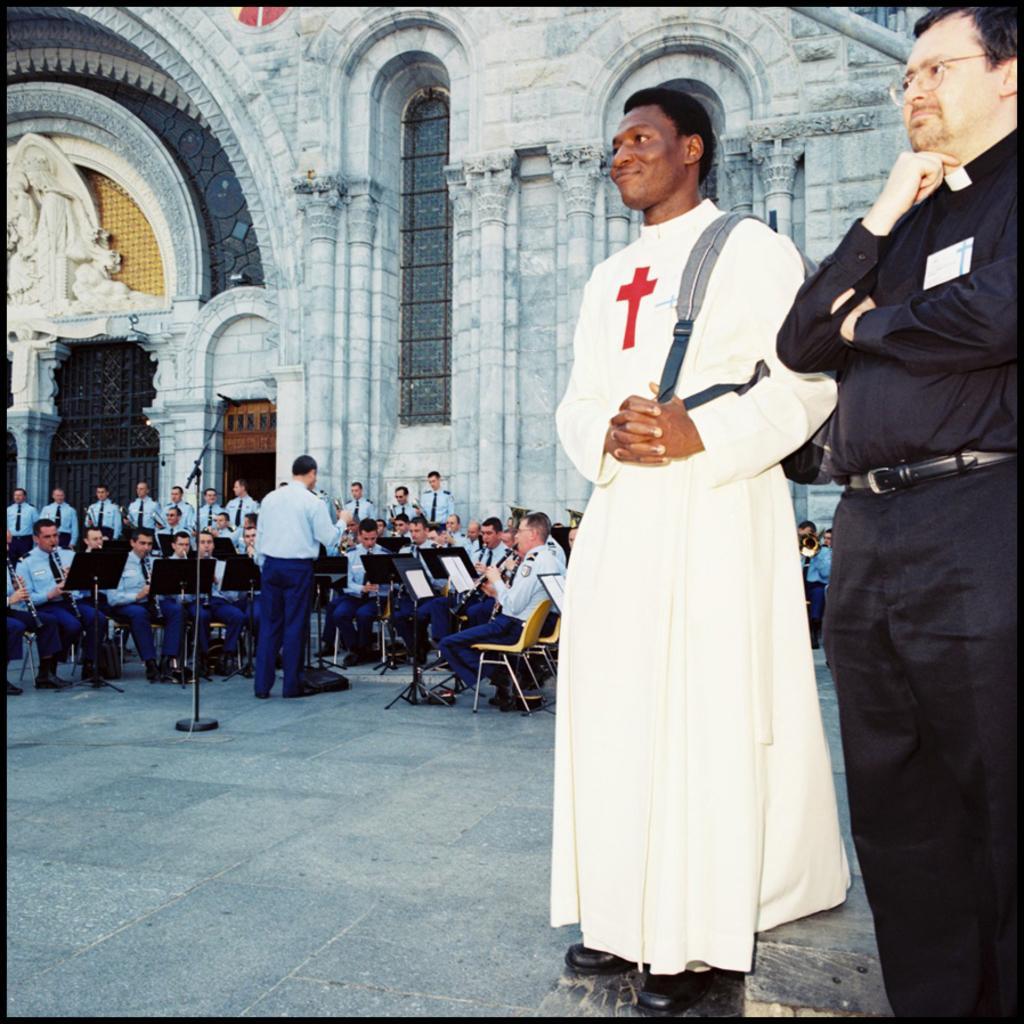In one or two sentences, can you explain what this image depicts? In this image we can see these people are standing on the road and these persons wearing blue shirts are sitting on the chairs and playing musical instruments. In the background, we can see the stone building. 